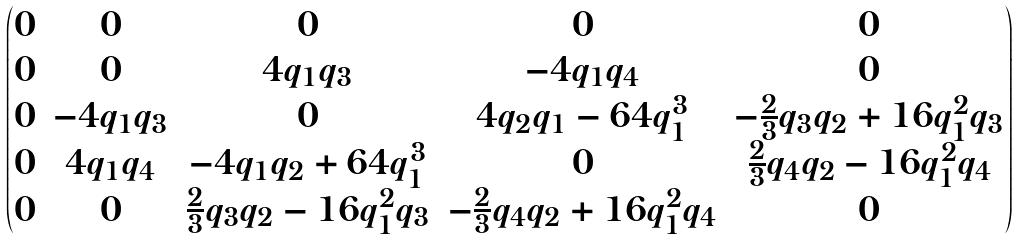<formula> <loc_0><loc_0><loc_500><loc_500>\begin{pmatrix} 0 & 0 & 0 & 0 & 0 \\ 0 & 0 & 4 q _ { 1 } q _ { 3 } & - 4 q _ { 1 } q _ { 4 } & 0 \\ 0 & - 4 q _ { 1 } q _ { 3 } & 0 & 4 q _ { 2 } q _ { 1 } - 6 4 q _ { 1 } ^ { 3 } & - \frac { 2 } { 3 } q _ { 3 } q _ { 2 } + 1 6 q _ { 1 } ^ { 2 } q _ { 3 } \\ 0 & 4 q _ { 1 } q _ { 4 } & - 4 q _ { 1 } q _ { 2 } + 6 4 q _ { 1 } ^ { 3 } & 0 & \frac { 2 } { 3 } q _ { 4 } q _ { 2 } - 1 6 q _ { 1 } ^ { 2 } q _ { 4 } \\ 0 & 0 & \frac { 2 } { 3 } q _ { 3 } q _ { 2 } - 1 6 q _ { 1 } ^ { 2 } q _ { 3 } & - \frac { 2 } { 3 } q _ { 4 } q _ { 2 } + 1 6 q _ { 1 } ^ { 2 } q _ { 4 } & 0 \end{pmatrix}</formula> 